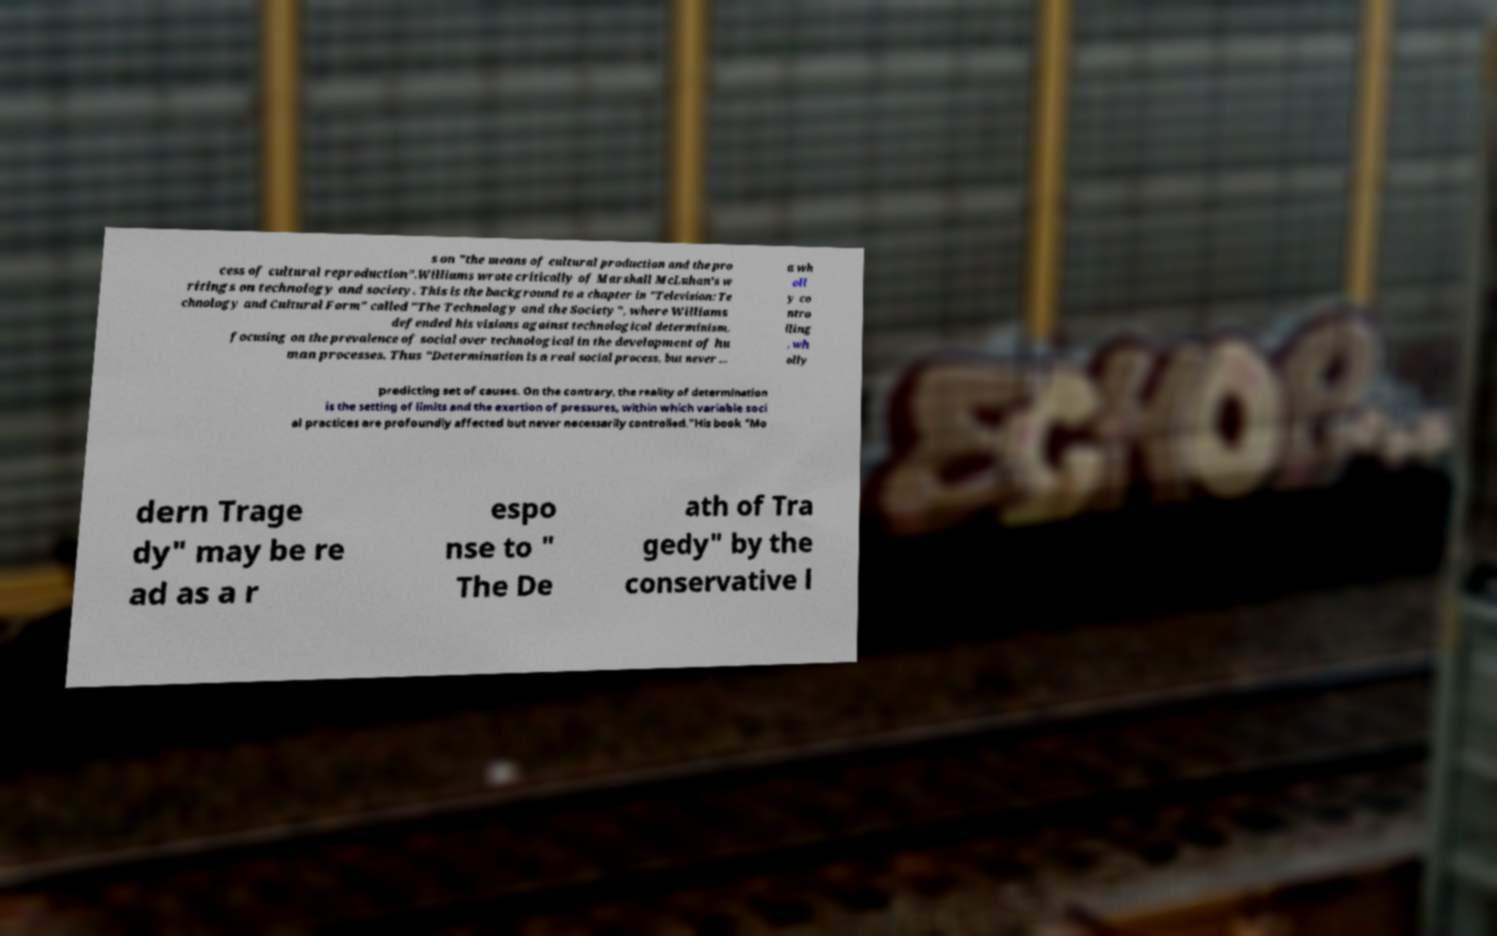I need the written content from this picture converted into text. Can you do that? s on "the means of cultural production and the pro cess of cultural reproduction".Williams wrote critically of Marshall McLuhan's w ritings on technology and society. This is the background to a chapter in "Television: Te chnology and Cultural Form" called "The Technology and the Society", where Williams defended his visions against technological determinism, focusing on the prevalence of social over technological in the development of hu man processes. Thus "Determination is a real social process, but never ... a wh oll y co ntro lling , wh olly predicting set of causes. On the contrary, the reality of determination is the setting of limits and the exertion of pressures, within which variable soci al practices are profoundly affected but never necessarily controlled."His book "Mo dern Trage dy" may be re ad as a r espo nse to " The De ath of Tra gedy" by the conservative l 